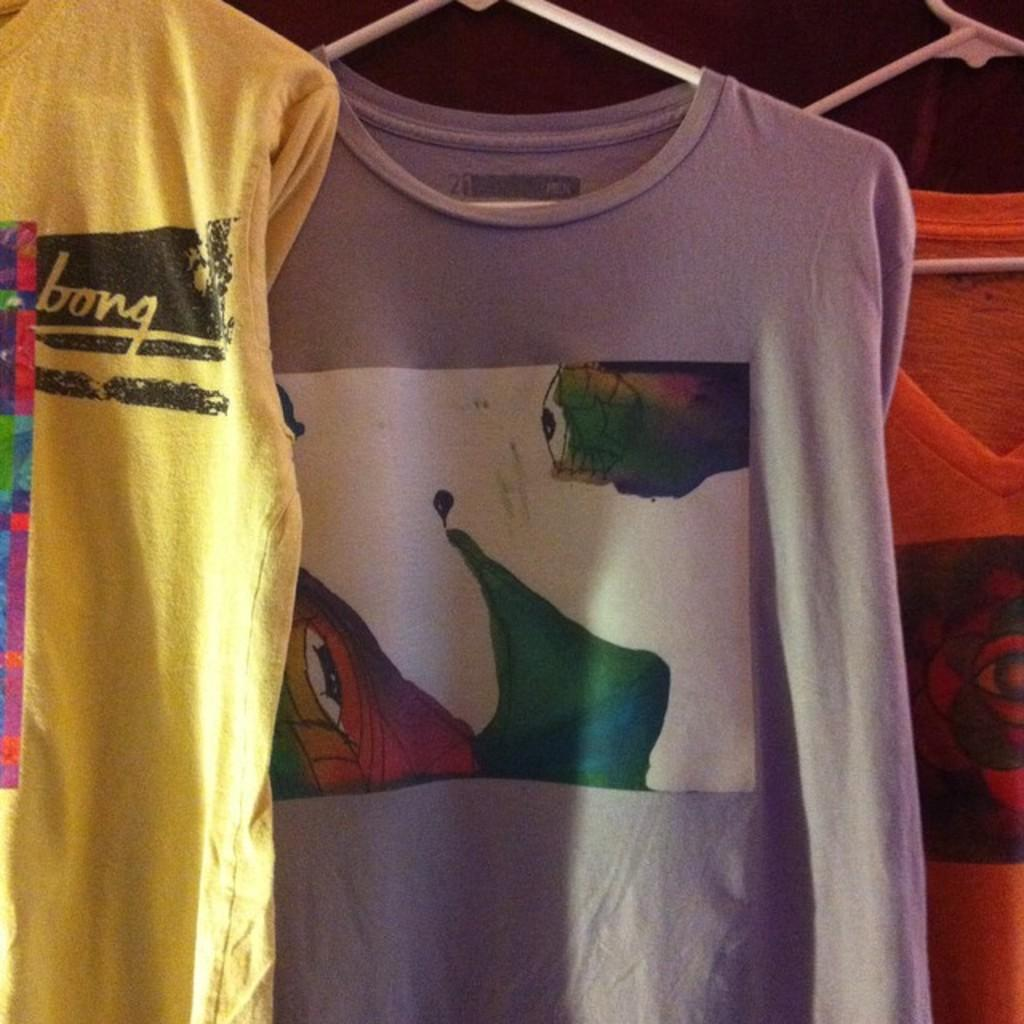What items can be seen in the image? There are clothes and hangers in the image. Where are the hangers located? The hangers are attached to a wall. How are the clothes being stored or displayed in the image? The clothes are hung on the hangers, which are attached to the wall. Can you see a kitten playing in the shade under the clothes in the image? There is no kitten or shade present in the image; it only features clothes and hangers attached to a wall. 